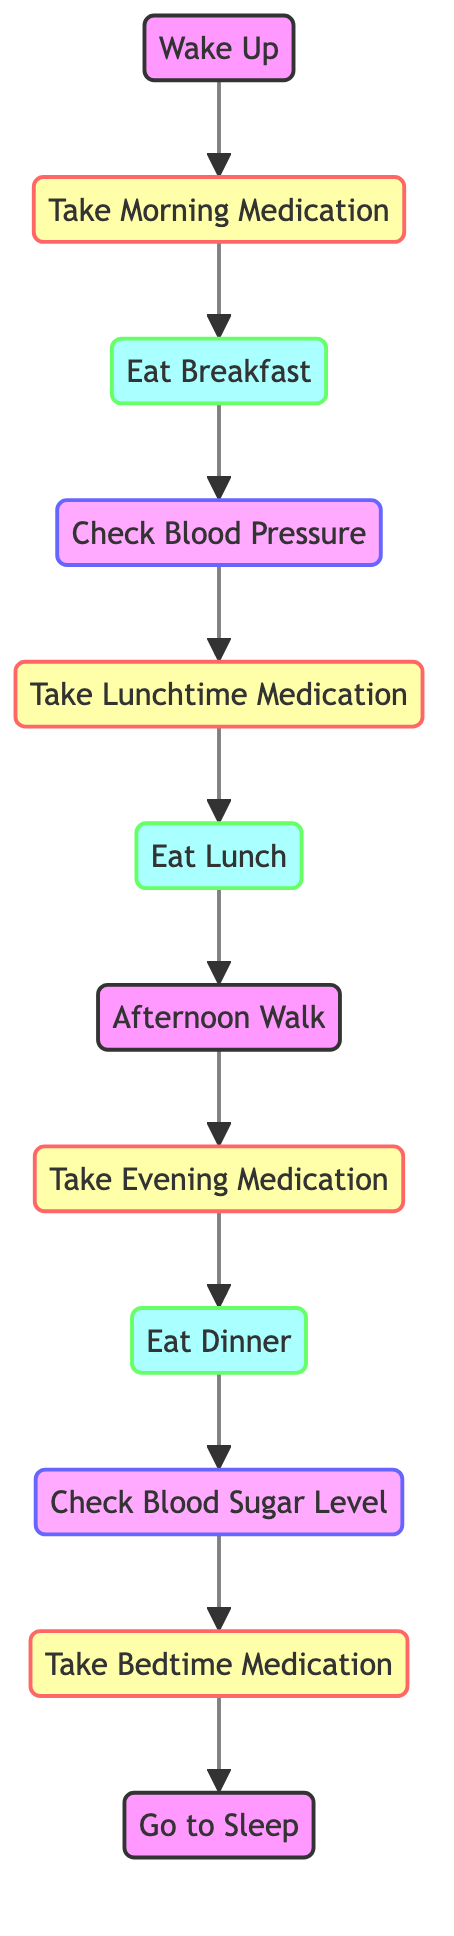What is the first action after waking up? According to the diagram, after the node "Wake Up", the next action to be taken is "Take Morning Medication". This follows the directed edge connecting these two nodes.
Answer: Take Morning Medication How many total actions are shown in the diagram? The diagram contains a total of 12 nodes representing various actions. Each of these actions corresponds to a specific event in the daily medication and health check routine.
Answer: 12 Which action follows the "Check Blood Pressure"? The directed edge from the "Check Blood Pressure" node leads to the "Take Lunchtime Medication" node, indicating that this is the subsequent action in the routine.
Answer: Take Lunchtime Medication How many medication-related actions are there? The nodes labeled for medication include "Take Morning Medication", "Take Lunchtime Medication", "Take Evening Medication", and "Take Bedtime Medication". There are four such nodes in total.
Answer: 4 What is the relationship between "Dinner" and "Check Blood Sugar Level"? In the directed graph, there is a directed edge from "Dinner" to "Check Blood Sugar Level", illustrating that checking blood sugar level occurs after eating dinner.
Answer: Dinner leads to Check Blood Sugar Level What are the last two actions before going to sleep? Before reaching the "Go to Sleep" node, the two preceding actions are "Take Bedtime Medication" and "Check Blood Sugar Level". The order flows from the medication to the sleep action.
Answer: Bedtime Medication, Check Blood Sugar Level Which action is performed right before "Eat Lunch"? The action prior to "Eat Lunch" is "Take Lunchtime Medication". This is determined by following the directed edge from the medication node to the lunch node.
Answer: Take Lunchtime Medication Is "Afternoon Walk" directly connected to any medication action? The "Afternoon Walk" node does not have a direct edge leading to or coming from any medication-related action. Instead, it appears after "Eat Lunch" and before the evening medication.
Answer: No What is the total number of edges in the diagram? Each directed connection between the nodes represents an edge. By counting all connections from one node to another in the structure, we find that there are 11 edges total in the diagram.
Answer: 11 